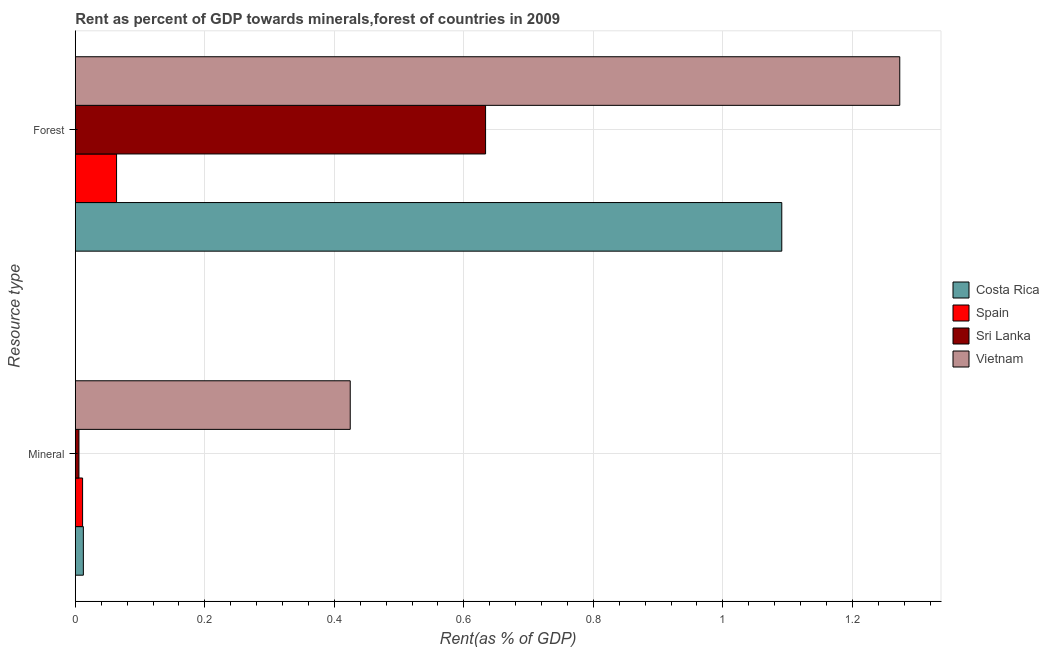How many groups of bars are there?
Give a very brief answer. 2. Are the number of bars per tick equal to the number of legend labels?
Offer a terse response. Yes. How many bars are there on the 1st tick from the top?
Your response must be concise. 4. What is the label of the 2nd group of bars from the top?
Ensure brevity in your answer.  Mineral. What is the mineral rent in Spain?
Make the answer very short. 0.01. Across all countries, what is the maximum forest rent?
Your response must be concise. 1.27. Across all countries, what is the minimum forest rent?
Provide a succinct answer. 0.06. In which country was the mineral rent maximum?
Give a very brief answer. Vietnam. In which country was the mineral rent minimum?
Keep it short and to the point. Sri Lanka. What is the total mineral rent in the graph?
Offer a very short reply. 0.45. What is the difference between the forest rent in Spain and that in Sri Lanka?
Provide a succinct answer. -0.57. What is the difference between the mineral rent in Vietnam and the forest rent in Sri Lanka?
Ensure brevity in your answer.  -0.21. What is the average mineral rent per country?
Your answer should be compact. 0.11. What is the difference between the mineral rent and forest rent in Spain?
Your response must be concise. -0.05. In how many countries, is the forest rent greater than 0.32 %?
Your answer should be compact. 3. What is the ratio of the forest rent in Spain to that in Sri Lanka?
Give a very brief answer. 0.1. What does the 4th bar from the top in Forest represents?
Your answer should be very brief. Costa Rica. How many countries are there in the graph?
Your answer should be compact. 4. What is the difference between two consecutive major ticks on the X-axis?
Your answer should be compact. 0.2. Are the values on the major ticks of X-axis written in scientific E-notation?
Your answer should be compact. No. Where does the legend appear in the graph?
Give a very brief answer. Center right. How many legend labels are there?
Keep it short and to the point. 4. What is the title of the graph?
Your response must be concise. Rent as percent of GDP towards minerals,forest of countries in 2009. What is the label or title of the X-axis?
Ensure brevity in your answer.  Rent(as % of GDP). What is the label or title of the Y-axis?
Provide a short and direct response. Resource type. What is the Rent(as % of GDP) of Costa Rica in Mineral?
Your answer should be very brief. 0.01. What is the Rent(as % of GDP) of Spain in Mineral?
Provide a succinct answer. 0.01. What is the Rent(as % of GDP) in Sri Lanka in Mineral?
Offer a terse response. 0.01. What is the Rent(as % of GDP) of Vietnam in Mineral?
Ensure brevity in your answer.  0.42. What is the Rent(as % of GDP) of Costa Rica in Forest?
Ensure brevity in your answer.  1.09. What is the Rent(as % of GDP) of Spain in Forest?
Give a very brief answer. 0.06. What is the Rent(as % of GDP) in Sri Lanka in Forest?
Your response must be concise. 0.63. What is the Rent(as % of GDP) in Vietnam in Forest?
Your answer should be compact. 1.27. Across all Resource type, what is the maximum Rent(as % of GDP) in Costa Rica?
Your answer should be very brief. 1.09. Across all Resource type, what is the maximum Rent(as % of GDP) in Spain?
Your answer should be very brief. 0.06. Across all Resource type, what is the maximum Rent(as % of GDP) of Sri Lanka?
Keep it short and to the point. 0.63. Across all Resource type, what is the maximum Rent(as % of GDP) of Vietnam?
Make the answer very short. 1.27. Across all Resource type, what is the minimum Rent(as % of GDP) of Costa Rica?
Provide a succinct answer. 0.01. Across all Resource type, what is the minimum Rent(as % of GDP) in Spain?
Your answer should be very brief. 0.01. Across all Resource type, what is the minimum Rent(as % of GDP) in Sri Lanka?
Your answer should be compact. 0.01. Across all Resource type, what is the minimum Rent(as % of GDP) of Vietnam?
Keep it short and to the point. 0.42. What is the total Rent(as % of GDP) of Costa Rica in the graph?
Ensure brevity in your answer.  1.1. What is the total Rent(as % of GDP) in Spain in the graph?
Your response must be concise. 0.07. What is the total Rent(as % of GDP) of Sri Lanka in the graph?
Make the answer very short. 0.64. What is the total Rent(as % of GDP) of Vietnam in the graph?
Make the answer very short. 1.7. What is the difference between the Rent(as % of GDP) in Costa Rica in Mineral and that in Forest?
Provide a succinct answer. -1.08. What is the difference between the Rent(as % of GDP) of Spain in Mineral and that in Forest?
Your answer should be compact. -0.05. What is the difference between the Rent(as % of GDP) in Sri Lanka in Mineral and that in Forest?
Give a very brief answer. -0.63. What is the difference between the Rent(as % of GDP) of Vietnam in Mineral and that in Forest?
Offer a very short reply. -0.85. What is the difference between the Rent(as % of GDP) in Costa Rica in Mineral and the Rent(as % of GDP) in Spain in Forest?
Your answer should be very brief. -0.05. What is the difference between the Rent(as % of GDP) in Costa Rica in Mineral and the Rent(as % of GDP) in Sri Lanka in Forest?
Offer a very short reply. -0.62. What is the difference between the Rent(as % of GDP) in Costa Rica in Mineral and the Rent(as % of GDP) in Vietnam in Forest?
Provide a short and direct response. -1.26. What is the difference between the Rent(as % of GDP) of Spain in Mineral and the Rent(as % of GDP) of Sri Lanka in Forest?
Make the answer very short. -0.62. What is the difference between the Rent(as % of GDP) in Spain in Mineral and the Rent(as % of GDP) in Vietnam in Forest?
Provide a succinct answer. -1.26. What is the difference between the Rent(as % of GDP) of Sri Lanka in Mineral and the Rent(as % of GDP) of Vietnam in Forest?
Give a very brief answer. -1.27. What is the average Rent(as % of GDP) in Costa Rica per Resource type?
Ensure brevity in your answer.  0.55. What is the average Rent(as % of GDP) of Spain per Resource type?
Your answer should be very brief. 0.04. What is the average Rent(as % of GDP) in Sri Lanka per Resource type?
Ensure brevity in your answer.  0.32. What is the average Rent(as % of GDP) in Vietnam per Resource type?
Your answer should be compact. 0.85. What is the difference between the Rent(as % of GDP) of Costa Rica and Rent(as % of GDP) of Spain in Mineral?
Keep it short and to the point. 0. What is the difference between the Rent(as % of GDP) in Costa Rica and Rent(as % of GDP) in Sri Lanka in Mineral?
Give a very brief answer. 0.01. What is the difference between the Rent(as % of GDP) in Costa Rica and Rent(as % of GDP) in Vietnam in Mineral?
Your answer should be compact. -0.41. What is the difference between the Rent(as % of GDP) in Spain and Rent(as % of GDP) in Sri Lanka in Mineral?
Offer a very short reply. 0.01. What is the difference between the Rent(as % of GDP) in Spain and Rent(as % of GDP) in Vietnam in Mineral?
Keep it short and to the point. -0.41. What is the difference between the Rent(as % of GDP) in Sri Lanka and Rent(as % of GDP) in Vietnam in Mineral?
Your answer should be very brief. -0.42. What is the difference between the Rent(as % of GDP) in Costa Rica and Rent(as % of GDP) in Spain in Forest?
Make the answer very short. 1.03. What is the difference between the Rent(as % of GDP) in Costa Rica and Rent(as % of GDP) in Sri Lanka in Forest?
Give a very brief answer. 0.46. What is the difference between the Rent(as % of GDP) in Costa Rica and Rent(as % of GDP) in Vietnam in Forest?
Make the answer very short. -0.18. What is the difference between the Rent(as % of GDP) in Spain and Rent(as % of GDP) in Sri Lanka in Forest?
Offer a terse response. -0.57. What is the difference between the Rent(as % of GDP) of Spain and Rent(as % of GDP) of Vietnam in Forest?
Your answer should be very brief. -1.21. What is the difference between the Rent(as % of GDP) in Sri Lanka and Rent(as % of GDP) in Vietnam in Forest?
Your response must be concise. -0.64. What is the ratio of the Rent(as % of GDP) of Costa Rica in Mineral to that in Forest?
Keep it short and to the point. 0.01. What is the ratio of the Rent(as % of GDP) in Spain in Mineral to that in Forest?
Offer a very short reply. 0.18. What is the ratio of the Rent(as % of GDP) of Sri Lanka in Mineral to that in Forest?
Your answer should be compact. 0.01. What is the ratio of the Rent(as % of GDP) in Vietnam in Mineral to that in Forest?
Your response must be concise. 0.33. What is the difference between the highest and the second highest Rent(as % of GDP) in Costa Rica?
Make the answer very short. 1.08. What is the difference between the highest and the second highest Rent(as % of GDP) in Spain?
Make the answer very short. 0.05. What is the difference between the highest and the second highest Rent(as % of GDP) of Sri Lanka?
Offer a very short reply. 0.63. What is the difference between the highest and the second highest Rent(as % of GDP) of Vietnam?
Provide a succinct answer. 0.85. What is the difference between the highest and the lowest Rent(as % of GDP) of Costa Rica?
Your answer should be compact. 1.08. What is the difference between the highest and the lowest Rent(as % of GDP) of Spain?
Ensure brevity in your answer.  0.05. What is the difference between the highest and the lowest Rent(as % of GDP) in Sri Lanka?
Your answer should be compact. 0.63. What is the difference between the highest and the lowest Rent(as % of GDP) in Vietnam?
Give a very brief answer. 0.85. 